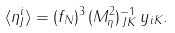Convert formula to latex. <formula><loc_0><loc_0><loc_500><loc_500>\langle \eta ^ { i } _ { J } \rangle = ( f _ { N } ) ^ { 3 } \, ( M _ { \eta } ^ { 2 } ) ^ { - 1 } _ { \, J K } \, y _ { i K } .</formula> 